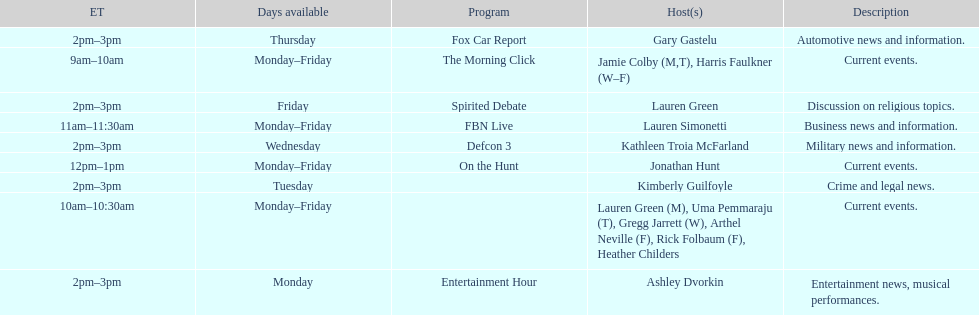What is the length of the defcon 3 program? 1 hour. 